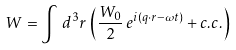Convert formula to latex. <formula><loc_0><loc_0><loc_500><loc_500>W = \int \, d ^ { 3 } r \, \left ( \frac { W _ { 0 } } { 2 } \, e ^ { i ( q \cdot r - \omega t ) } + c . c . \right )</formula> 